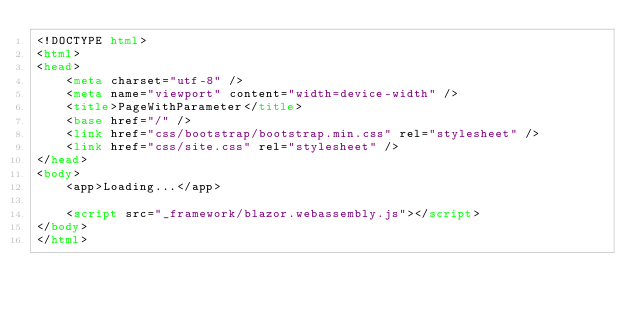<code> <loc_0><loc_0><loc_500><loc_500><_HTML_><!DOCTYPE html>
<html>
<head>
    <meta charset="utf-8" />
    <meta name="viewport" content="width=device-width" />
    <title>PageWithParameter</title>
    <base href="/" />
    <link href="css/bootstrap/bootstrap.min.css" rel="stylesheet" />
    <link href="css/site.css" rel="stylesheet" />
</head>
<body>
    <app>Loading...</app>

    <script src="_framework/blazor.webassembly.js"></script>
</body>
</html>
</code> 